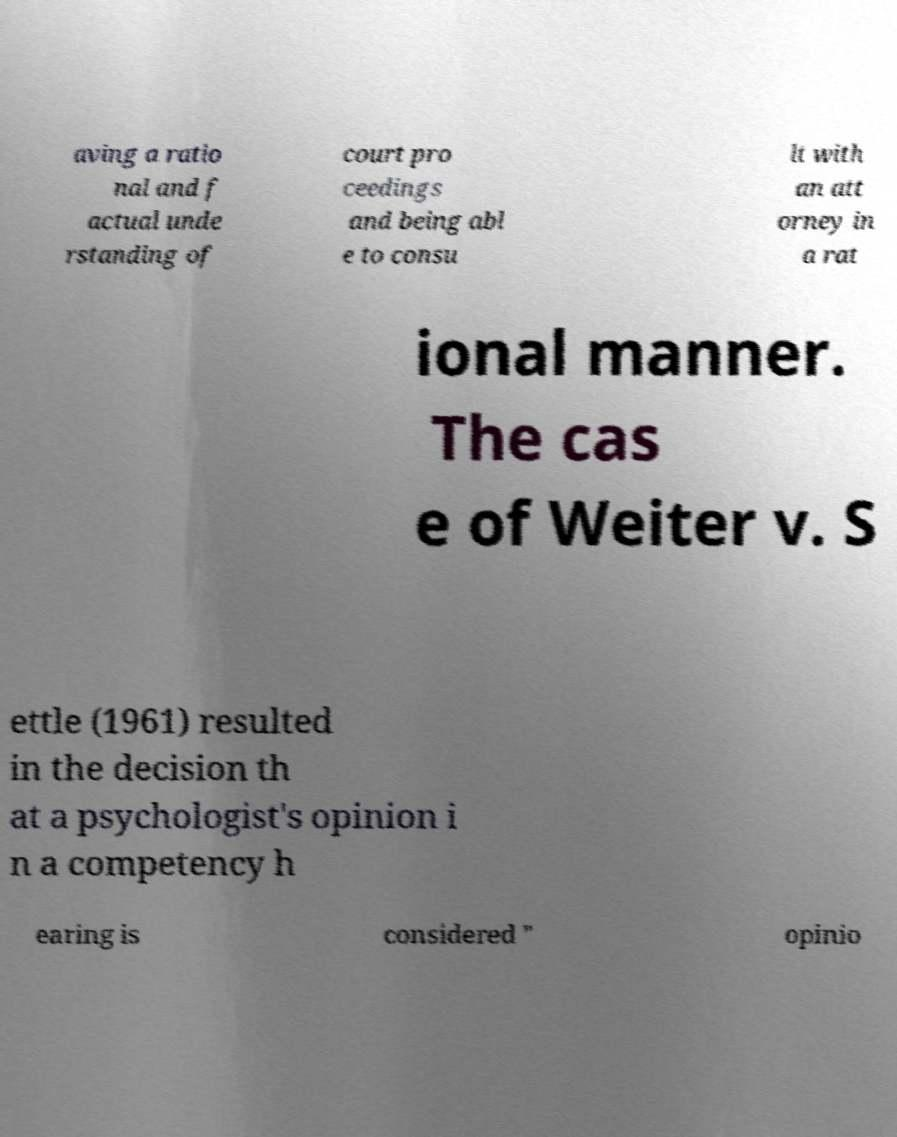Can you read and provide the text displayed in the image?This photo seems to have some interesting text. Can you extract and type it out for me? aving a ratio nal and f actual unde rstanding of court pro ceedings and being abl e to consu lt with an att orney in a rat ional manner. The cas e of Weiter v. S ettle (1961) resulted in the decision th at a psychologist's opinion i n a competency h earing is considered " opinio 